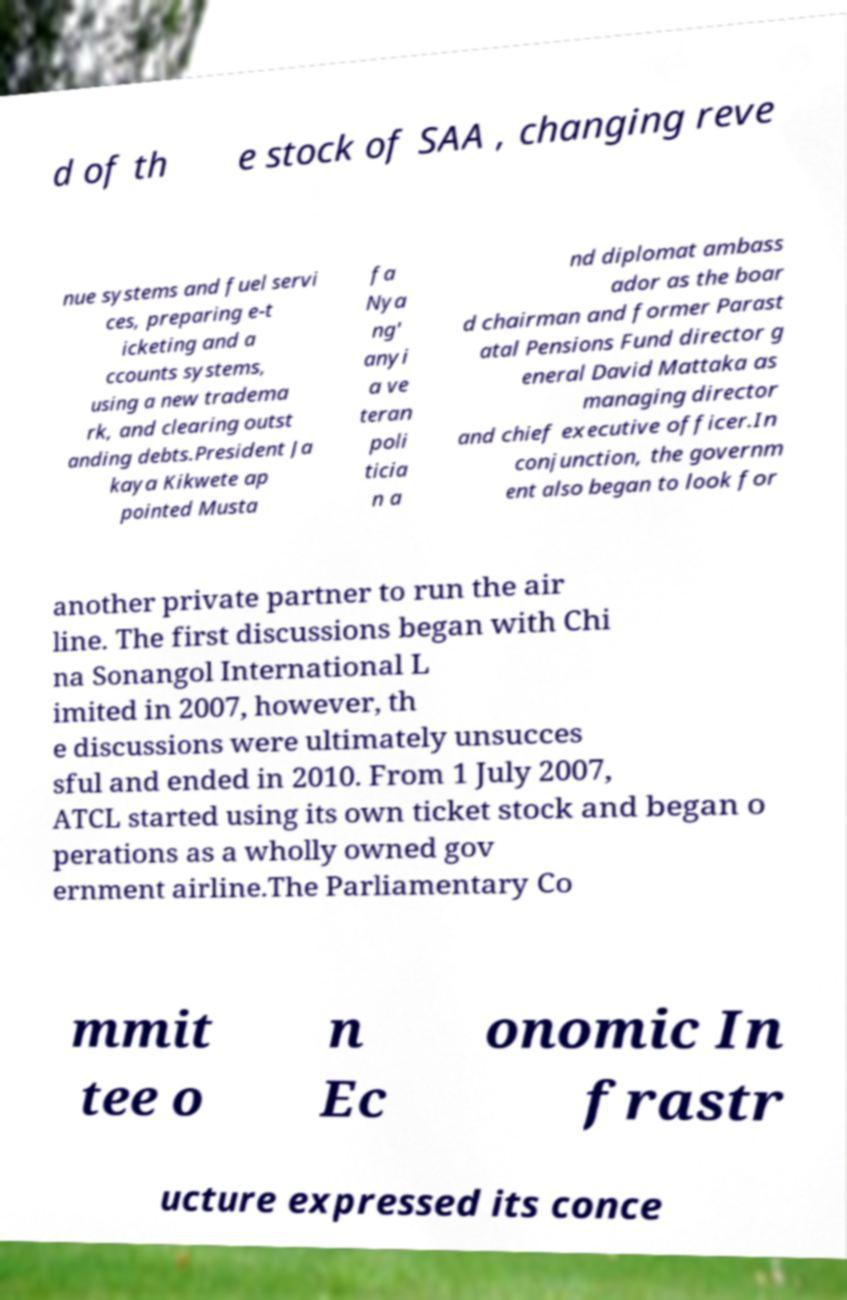What messages or text are displayed in this image? I need them in a readable, typed format. d of th e stock of SAA , changing reve nue systems and fuel servi ces, preparing e-t icketing and a ccounts systems, using a new tradema rk, and clearing outst anding debts.President Ja kaya Kikwete ap pointed Musta fa Nya ng' anyi a ve teran poli ticia n a nd diplomat ambass ador as the boar d chairman and former Parast atal Pensions Fund director g eneral David Mattaka as managing director and chief executive officer.In conjunction, the governm ent also began to look for another private partner to run the air line. The first discussions began with Chi na Sonangol International L imited in 2007, however, th e discussions were ultimately unsucces sful and ended in 2010. From 1 July 2007, ATCL started using its own ticket stock and began o perations as a wholly owned gov ernment airline.The Parliamentary Co mmit tee o n Ec onomic In frastr ucture expressed its conce 